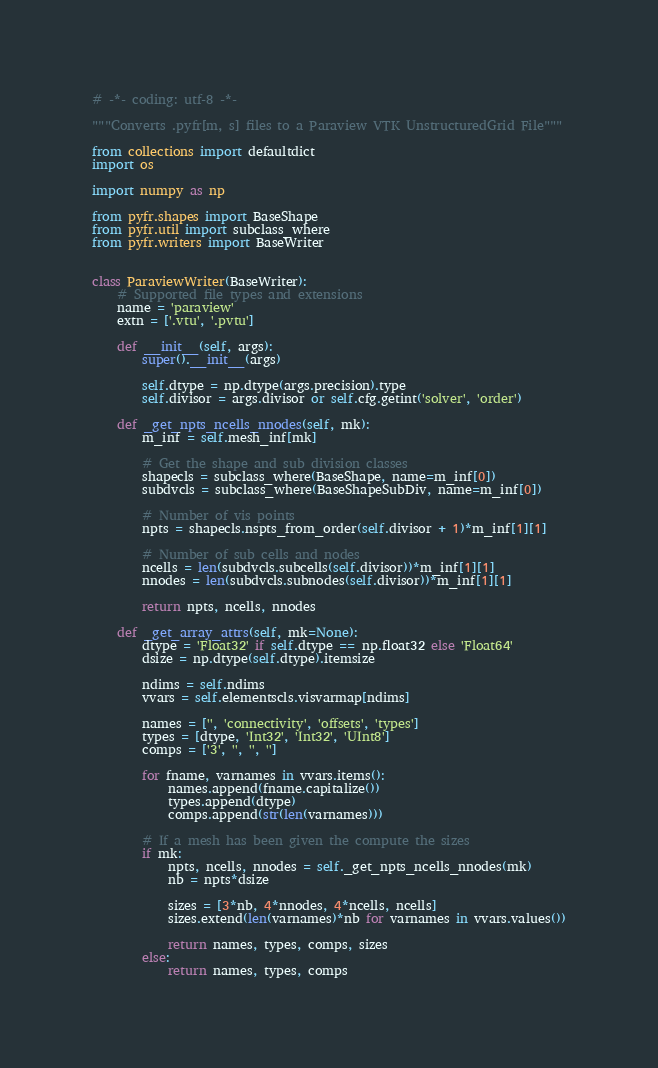Convert code to text. <code><loc_0><loc_0><loc_500><loc_500><_Python_># -*- coding: utf-8 -*-

"""Converts .pyfr[m, s] files to a Paraview VTK UnstructuredGrid File"""

from collections import defaultdict
import os

import numpy as np

from pyfr.shapes import BaseShape
from pyfr.util import subclass_where
from pyfr.writers import BaseWriter


class ParaviewWriter(BaseWriter):
    # Supported file types and extensions
    name = 'paraview'
    extn = ['.vtu', '.pvtu']

    def __init__(self, args):
        super().__init__(args)

        self.dtype = np.dtype(args.precision).type
        self.divisor = args.divisor or self.cfg.getint('solver', 'order')

    def _get_npts_ncells_nnodes(self, mk):
        m_inf = self.mesh_inf[mk]

        # Get the shape and sub division classes
        shapecls = subclass_where(BaseShape, name=m_inf[0])
        subdvcls = subclass_where(BaseShapeSubDiv, name=m_inf[0])

        # Number of vis points
        npts = shapecls.nspts_from_order(self.divisor + 1)*m_inf[1][1]

        # Number of sub cells and nodes
        ncells = len(subdvcls.subcells(self.divisor))*m_inf[1][1]
        nnodes = len(subdvcls.subnodes(self.divisor))*m_inf[1][1]

        return npts, ncells, nnodes

    def _get_array_attrs(self, mk=None):
        dtype = 'Float32' if self.dtype == np.float32 else 'Float64'
        dsize = np.dtype(self.dtype).itemsize

        ndims = self.ndims
        vvars = self.elementscls.visvarmap[ndims]

        names = ['', 'connectivity', 'offsets', 'types']
        types = [dtype, 'Int32', 'Int32', 'UInt8']
        comps = ['3', '', '', '']

        for fname, varnames in vvars.items():
            names.append(fname.capitalize())
            types.append(dtype)
            comps.append(str(len(varnames)))

        # If a mesh has been given the compute the sizes
        if mk:
            npts, ncells, nnodes = self._get_npts_ncells_nnodes(mk)
            nb = npts*dsize

            sizes = [3*nb, 4*nnodes, 4*ncells, ncells]
            sizes.extend(len(varnames)*nb for varnames in vvars.values())

            return names, types, comps, sizes
        else:
            return names, types, comps
</code> 